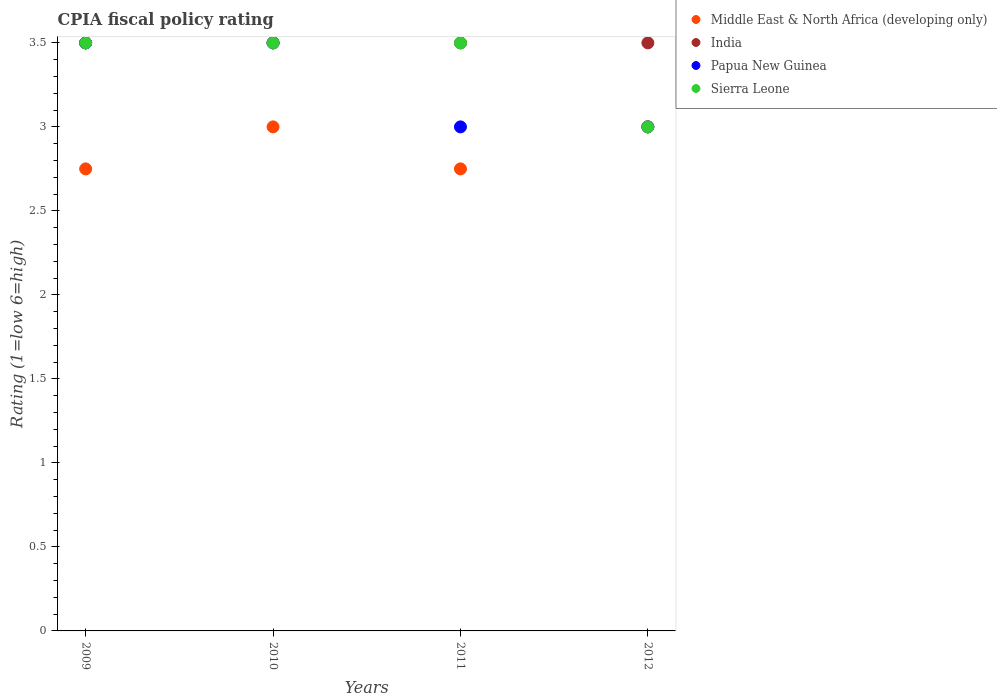What is the CPIA rating in India in 2010?
Your response must be concise. 3.5. Across all years, what is the minimum CPIA rating in Sierra Leone?
Make the answer very short. 3. In which year was the CPIA rating in India minimum?
Give a very brief answer. 2009. What is the difference between the CPIA rating in Papua New Guinea in 2011 and the CPIA rating in Middle East & North Africa (developing only) in 2009?
Provide a succinct answer. 0.25. What is the average CPIA rating in Middle East & North Africa (developing only) per year?
Ensure brevity in your answer.  2.88. In the year 2011, what is the difference between the CPIA rating in Middle East & North Africa (developing only) and CPIA rating in Papua New Guinea?
Offer a very short reply. -0.25. In how many years, is the CPIA rating in India greater than 1.8?
Your answer should be compact. 4. What is the ratio of the CPIA rating in Papua New Guinea in 2009 to that in 2011?
Your response must be concise. 1.17. Is the CPIA rating in Middle East & North Africa (developing only) in 2009 less than that in 2010?
Your answer should be compact. Yes. In how many years, is the CPIA rating in India greater than the average CPIA rating in India taken over all years?
Your answer should be very brief. 0. Is the sum of the CPIA rating in Middle East & North Africa (developing only) in 2009 and 2012 greater than the maximum CPIA rating in India across all years?
Provide a succinct answer. Yes. Is it the case that in every year, the sum of the CPIA rating in India and CPIA rating in Middle East & North Africa (developing only)  is greater than the sum of CPIA rating in Sierra Leone and CPIA rating in Papua New Guinea?
Give a very brief answer. No. Does the CPIA rating in India monotonically increase over the years?
Give a very brief answer. No. Is the CPIA rating in Sierra Leone strictly greater than the CPIA rating in Papua New Guinea over the years?
Ensure brevity in your answer.  No. Is the CPIA rating in Sierra Leone strictly less than the CPIA rating in Papua New Guinea over the years?
Your answer should be compact. No. How many dotlines are there?
Offer a very short reply. 4. What is the difference between two consecutive major ticks on the Y-axis?
Provide a short and direct response. 0.5. Does the graph contain any zero values?
Keep it short and to the point. No. Where does the legend appear in the graph?
Your answer should be very brief. Top right. What is the title of the graph?
Your response must be concise. CPIA fiscal policy rating. Does "Libya" appear as one of the legend labels in the graph?
Give a very brief answer. No. What is the label or title of the Y-axis?
Make the answer very short. Rating (1=low 6=high). What is the Rating (1=low 6=high) in Middle East & North Africa (developing only) in 2009?
Ensure brevity in your answer.  2.75. What is the Rating (1=low 6=high) of India in 2009?
Offer a terse response. 3.5. What is the Rating (1=low 6=high) in India in 2010?
Ensure brevity in your answer.  3.5. What is the Rating (1=low 6=high) in Papua New Guinea in 2010?
Keep it short and to the point. 3.5. What is the Rating (1=low 6=high) in Middle East & North Africa (developing only) in 2011?
Keep it short and to the point. 2.75. What is the Rating (1=low 6=high) in India in 2011?
Your answer should be compact. 3.5. What is the Rating (1=low 6=high) in Papua New Guinea in 2011?
Your answer should be compact. 3. What is the Rating (1=low 6=high) of Sierra Leone in 2011?
Offer a terse response. 3.5. What is the Rating (1=low 6=high) of Middle East & North Africa (developing only) in 2012?
Your answer should be compact. 3. What is the Rating (1=low 6=high) of Papua New Guinea in 2012?
Offer a terse response. 3. What is the Rating (1=low 6=high) in Sierra Leone in 2012?
Keep it short and to the point. 3. Across all years, what is the maximum Rating (1=low 6=high) of Middle East & North Africa (developing only)?
Offer a very short reply. 3. Across all years, what is the maximum Rating (1=low 6=high) in India?
Your answer should be very brief. 3.5. Across all years, what is the maximum Rating (1=low 6=high) of Papua New Guinea?
Give a very brief answer. 3.5. Across all years, what is the minimum Rating (1=low 6=high) of Middle East & North Africa (developing only)?
Provide a short and direct response. 2.75. Across all years, what is the minimum Rating (1=low 6=high) in India?
Your answer should be very brief. 3.5. What is the total Rating (1=low 6=high) of Middle East & North Africa (developing only) in the graph?
Provide a short and direct response. 11.5. What is the total Rating (1=low 6=high) in India in the graph?
Your response must be concise. 14. What is the total Rating (1=low 6=high) of Papua New Guinea in the graph?
Your answer should be compact. 13. What is the total Rating (1=low 6=high) in Sierra Leone in the graph?
Your answer should be very brief. 13.5. What is the difference between the Rating (1=low 6=high) of India in 2009 and that in 2010?
Your answer should be compact. 0. What is the difference between the Rating (1=low 6=high) in Papua New Guinea in 2009 and that in 2010?
Make the answer very short. 0. What is the difference between the Rating (1=low 6=high) of Sierra Leone in 2009 and that in 2010?
Give a very brief answer. 0. What is the difference between the Rating (1=low 6=high) of India in 2009 and that in 2011?
Give a very brief answer. 0. What is the difference between the Rating (1=low 6=high) in Papua New Guinea in 2009 and that in 2011?
Ensure brevity in your answer.  0.5. What is the difference between the Rating (1=low 6=high) of Sierra Leone in 2009 and that in 2011?
Your answer should be very brief. 0. What is the difference between the Rating (1=low 6=high) of Middle East & North Africa (developing only) in 2010 and that in 2011?
Provide a short and direct response. 0.25. What is the difference between the Rating (1=low 6=high) in India in 2010 and that in 2011?
Offer a very short reply. 0. What is the difference between the Rating (1=low 6=high) in Papua New Guinea in 2011 and that in 2012?
Provide a succinct answer. 0. What is the difference between the Rating (1=low 6=high) of Middle East & North Africa (developing only) in 2009 and the Rating (1=low 6=high) of India in 2010?
Ensure brevity in your answer.  -0.75. What is the difference between the Rating (1=low 6=high) of Middle East & North Africa (developing only) in 2009 and the Rating (1=low 6=high) of Papua New Guinea in 2010?
Give a very brief answer. -0.75. What is the difference between the Rating (1=low 6=high) in Middle East & North Africa (developing only) in 2009 and the Rating (1=low 6=high) in Sierra Leone in 2010?
Ensure brevity in your answer.  -0.75. What is the difference between the Rating (1=low 6=high) of India in 2009 and the Rating (1=low 6=high) of Papua New Guinea in 2010?
Your response must be concise. 0. What is the difference between the Rating (1=low 6=high) in India in 2009 and the Rating (1=low 6=high) in Sierra Leone in 2010?
Give a very brief answer. 0. What is the difference between the Rating (1=low 6=high) of Papua New Guinea in 2009 and the Rating (1=low 6=high) of Sierra Leone in 2010?
Give a very brief answer. 0. What is the difference between the Rating (1=low 6=high) in Middle East & North Africa (developing only) in 2009 and the Rating (1=low 6=high) in India in 2011?
Your answer should be compact. -0.75. What is the difference between the Rating (1=low 6=high) in Middle East & North Africa (developing only) in 2009 and the Rating (1=low 6=high) in Papua New Guinea in 2011?
Your answer should be very brief. -0.25. What is the difference between the Rating (1=low 6=high) of Middle East & North Africa (developing only) in 2009 and the Rating (1=low 6=high) of Sierra Leone in 2011?
Make the answer very short. -0.75. What is the difference between the Rating (1=low 6=high) in India in 2009 and the Rating (1=low 6=high) in Papua New Guinea in 2011?
Ensure brevity in your answer.  0.5. What is the difference between the Rating (1=low 6=high) in Middle East & North Africa (developing only) in 2009 and the Rating (1=low 6=high) in India in 2012?
Ensure brevity in your answer.  -0.75. What is the difference between the Rating (1=low 6=high) of Middle East & North Africa (developing only) in 2009 and the Rating (1=low 6=high) of Papua New Guinea in 2012?
Your response must be concise. -0.25. What is the difference between the Rating (1=low 6=high) in Middle East & North Africa (developing only) in 2009 and the Rating (1=low 6=high) in Sierra Leone in 2012?
Offer a very short reply. -0.25. What is the difference between the Rating (1=low 6=high) of India in 2009 and the Rating (1=low 6=high) of Papua New Guinea in 2012?
Offer a terse response. 0.5. What is the difference between the Rating (1=low 6=high) in India in 2009 and the Rating (1=low 6=high) in Sierra Leone in 2012?
Make the answer very short. 0.5. What is the difference between the Rating (1=low 6=high) in Papua New Guinea in 2009 and the Rating (1=low 6=high) in Sierra Leone in 2012?
Give a very brief answer. 0.5. What is the difference between the Rating (1=low 6=high) in Middle East & North Africa (developing only) in 2010 and the Rating (1=low 6=high) in India in 2011?
Make the answer very short. -0.5. What is the difference between the Rating (1=low 6=high) of Middle East & North Africa (developing only) in 2010 and the Rating (1=low 6=high) of Papua New Guinea in 2011?
Your answer should be very brief. 0. What is the difference between the Rating (1=low 6=high) in Papua New Guinea in 2010 and the Rating (1=low 6=high) in Sierra Leone in 2011?
Provide a succinct answer. 0. What is the difference between the Rating (1=low 6=high) of Middle East & North Africa (developing only) in 2010 and the Rating (1=low 6=high) of India in 2012?
Provide a short and direct response. -0.5. What is the difference between the Rating (1=low 6=high) of Middle East & North Africa (developing only) in 2010 and the Rating (1=low 6=high) of Papua New Guinea in 2012?
Provide a short and direct response. 0. What is the difference between the Rating (1=low 6=high) of Papua New Guinea in 2010 and the Rating (1=low 6=high) of Sierra Leone in 2012?
Provide a succinct answer. 0.5. What is the difference between the Rating (1=low 6=high) in Middle East & North Africa (developing only) in 2011 and the Rating (1=low 6=high) in India in 2012?
Provide a succinct answer. -0.75. What is the difference between the Rating (1=low 6=high) of India in 2011 and the Rating (1=low 6=high) of Papua New Guinea in 2012?
Offer a very short reply. 0.5. What is the difference between the Rating (1=low 6=high) of India in 2011 and the Rating (1=low 6=high) of Sierra Leone in 2012?
Provide a succinct answer. 0.5. What is the average Rating (1=low 6=high) in Middle East & North Africa (developing only) per year?
Ensure brevity in your answer.  2.88. What is the average Rating (1=low 6=high) in Papua New Guinea per year?
Make the answer very short. 3.25. What is the average Rating (1=low 6=high) in Sierra Leone per year?
Give a very brief answer. 3.38. In the year 2009, what is the difference between the Rating (1=low 6=high) of Middle East & North Africa (developing only) and Rating (1=low 6=high) of India?
Offer a terse response. -0.75. In the year 2009, what is the difference between the Rating (1=low 6=high) of Middle East & North Africa (developing only) and Rating (1=low 6=high) of Papua New Guinea?
Make the answer very short. -0.75. In the year 2009, what is the difference between the Rating (1=low 6=high) of Middle East & North Africa (developing only) and Rating (1=low 6=high) of Sierra Leone?
Provide a short and direct response. -0.75. In the year 2009, what is the difference between the Rating (1=low 6=high) of India and Rating (1=low 6=high) of Sierra Leone?
Give a very brief answer. 0. In the year 2009, what is the difference between the Rating (1=low 6=high) of Papua New Guinea and Rating (1=low 6=high) of Sierra Leone?
Keep it short and to the point. 0. In the year 2010, what is the difference between the Rating (1=low 6=high) in Middle East & North Africa (developing only) and Rating (1=low 6=high) in India?
Keep it short and to the point. -0.5. In the year 2010, what is the difference between the Rating (1=low 6=high) of Middle East & North Africa (developing only) and Rating (1=low 6=high) of Papua New Guinea?
Ensure brevity in your answer.  -0.5. In the year 2011, what is the difference between the Rating (1=low 6=high) in Middle East & North Africa (developing only) and Rating (1=low 6=high) in India?
Your response must be concise. -0.75. In the year 2011, what is the difference between the Rating (1=low 6=high) of Middle East & North Africa (developing only) and Rating (1=low 6=high) of Sierra Leone?
Offer a very short reply. -0.75. In the year 2011, what is the difference between the Rating (1=low 6=high) of India and Rating (1=low 6=high) of Papua New Guinea?
Make the answer very short. 0.5. In the year 2012, what is the difference between the Rating (1=low 6=high) in Middle East & North Africa (developing only) and Rating (1=low 6=high) in India?
Ensure brevity in your answer.  -0.5. In the year 2012, what is the difference between the Rating (1=low 6=high) in Middle East & North Africa (developing only) and Rating (1=low 6=high) in Sierra Leone?
Offer a very short reply. 0. In the year 2012, what is the difference between the Rating (1=low 6=high) in India and Rating (1=low 6=high) in Papua New Guinea?
Your answer should be compact. 0.5. In the year 2012, what is the difference between the Rating (1=low 6=high) of India and Rating (1=low 6=high) of Sierra Leone?
Provide a succinct answer. 0.5. In the year 2012, what is the difference between the Rating (1=low 6=high) in Papua New Guinea and Rating (1=low 6=high) in Sierra Leone?
Provide a short and direct response. 0. What is the ratio of the Rating (1=low 6=high) in Papua New Guinea in 2009 to that in 2010?
Your answer should be very brief. 1. What is the ratio of the Rating (1=low 6=high) of Middle East & North Africa (developing only) in 2009 to that in 2011?
Offer a very short reply. 1. What is the ratio of the Rating (1=low 6=high) of India in 2009 to that in 2011?
Give a very brief answer. 1. What is the ratio of the Rating (1=low 6=high) of Papua New Guinea in 2009 to that in 2011?
Your answer should be very brief. 1.17. What is the ratio of the Rating (1=low 6=high) of Middle East & North Africa (developing only) in 2009 to that in 2012?
Offer a very short reply. 0.92. What is the ratio of the Rating (1=low 6=high) of Papua New Guinea in 2009 to that in 2012?
Offer a terse response. 1.17. What is the ratio of the Rating (1=low 6=high) in India in 2010 to that in 2011?
Give a very brief answer. 1. What is the ratio of the Rating (1=low 6=high) of Sierra Leone in 2010 to that in 2011?
Provide a succinct answer. 1. What is the ratio of the Rating (1=low 6=high) of India in 2010 to that in 2012?
Ensure brevity in your answer.  1. What is the ratio of the Rating (1=low 6=high) of Sierra Leone in 2010 to that in 2012?
Provide a short and direct response. 1.17. What is the ratio of the Rating (1=low 6=high) in Sierra Leone in 2011 to that in 2012?
Provide a succinct answer. 1.17. What is the difference between the highest and the second highest Rating (1=low 6=high) in Middle East & North Africa (developing only)?
Provide a succinct answer. 0. What is the difference between the highest and the second highest Rating (1=low 6=high) of Papua New Guinea?
Offer a terse response. 0. What is the difference between the highest and the lowest Rating (1=low 6=high) in India?
Give a very brief answer. 0. What is the difference between the highest and the lowest Rating (1=low 6=high) in Sierra Leone?
Make the answer very short. 0.5. 